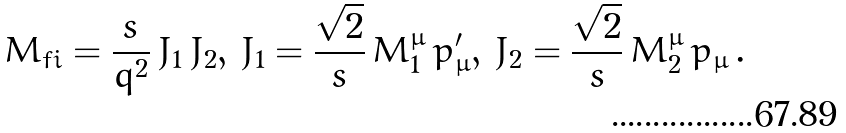Convert formula to latex. <formula><loc_0><loc_0><loc_500><loc_500>M _ { f i } = { \frac { s } { q ^ { 2 } } } \, J _ { 1 } \, J _ { 2 } , \, J _ { 1 } = { \frac { \sqrt { 2 } } { s } } \, M _ { 1 } ^ { \mu } \, p _ { \mu } ^ { \prime } , \, J _ { 2 } = { \frac { \sqrt { 2 } } { s } } \, M _ { 2 } ^ { \mu } \, p _ { \mu } \, .</formula> 